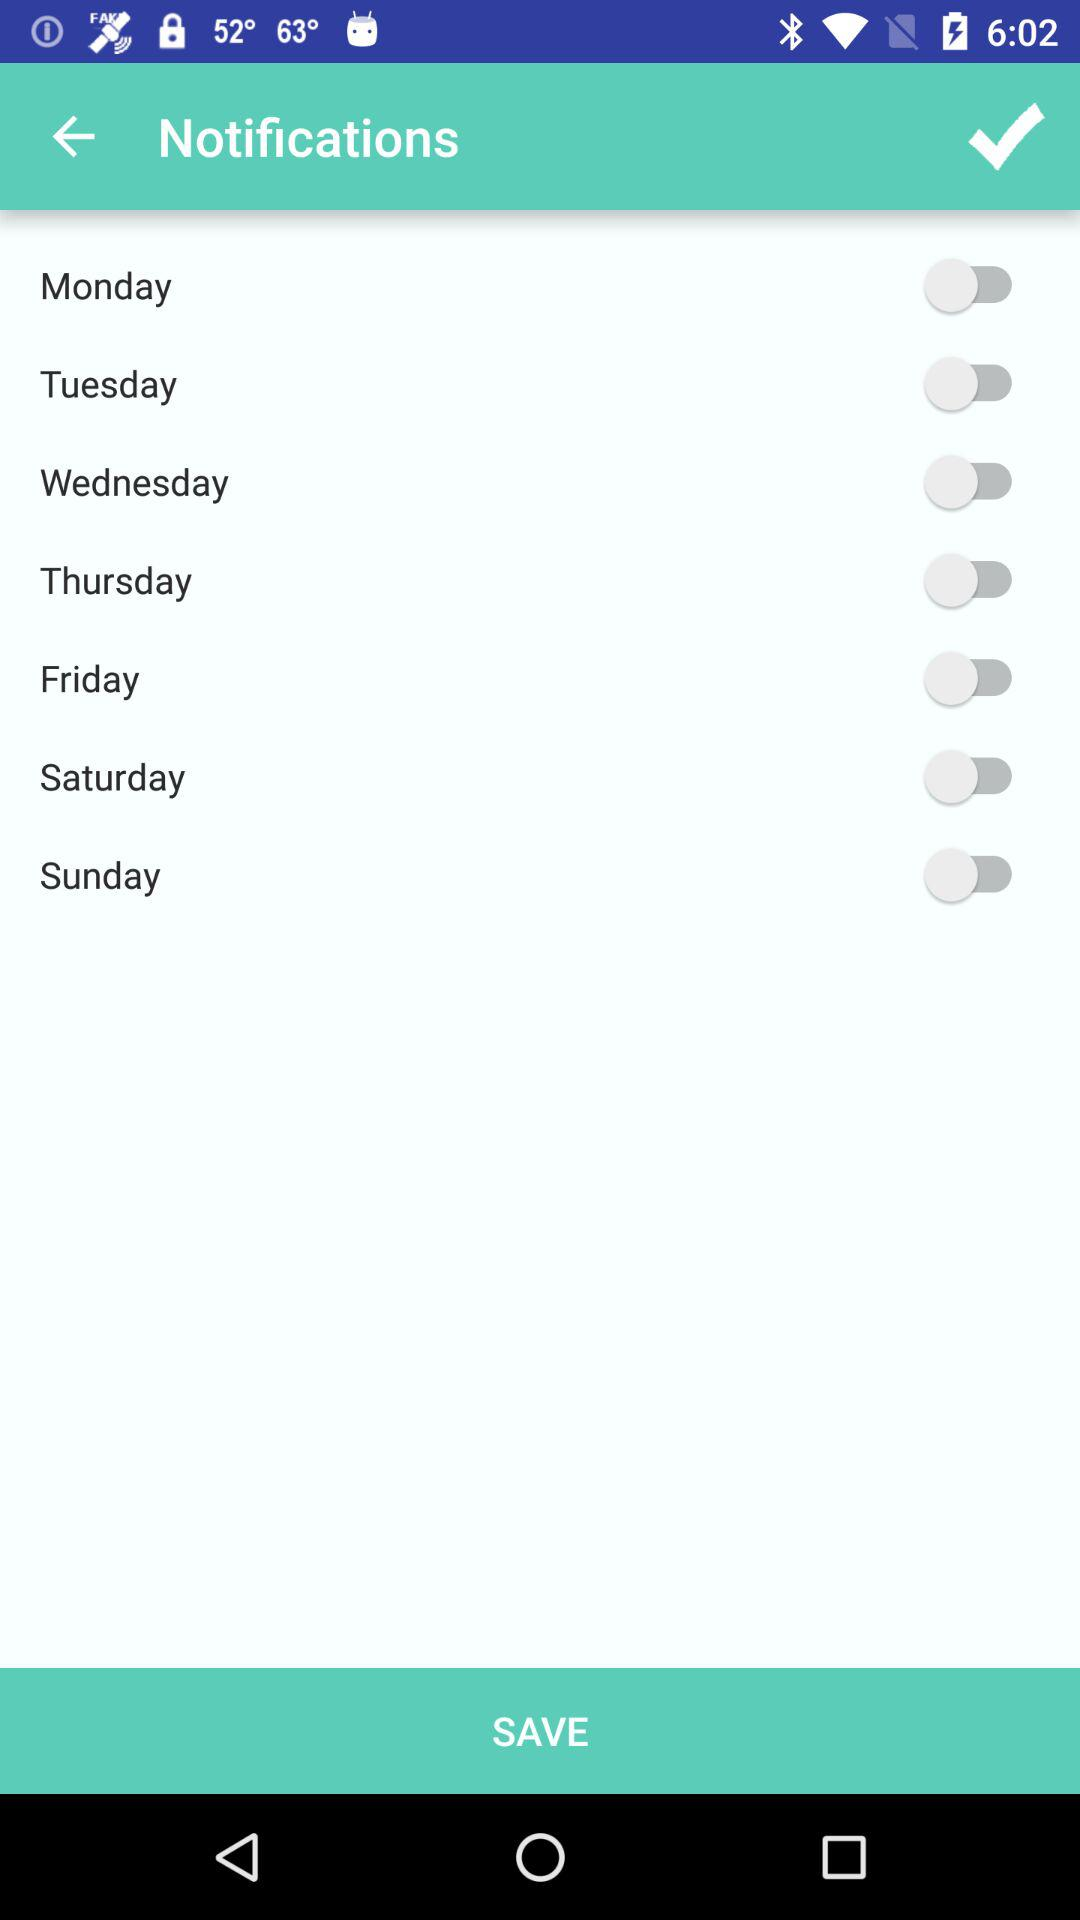What is the status of "Monday"? The status is "off". 